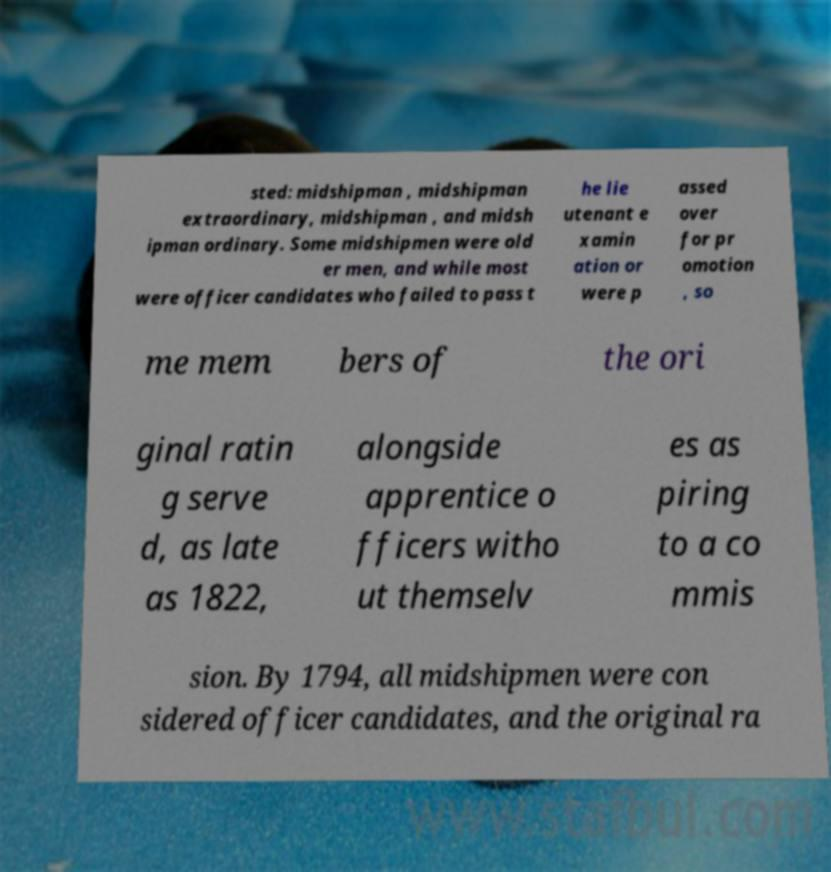What messages or text are displayed in this image? I need them in a readable, typed format. sted: midshipman , midshipman extraordinary, midshipman , and midsh ipman ordinary. Some midshipmen were old er men, and while most were officer candidates who failed to pass t he lie utenant e xamin ation or were p assed over for pr omotion , so me mem bers of the ori ginal ratin g serve d, as late as 1822, alongside apprentice o fficers witho ut themselv es as piring to a co mmis sion. By 1794, all midshipmen were con sidered officer candidates, and the original ra 